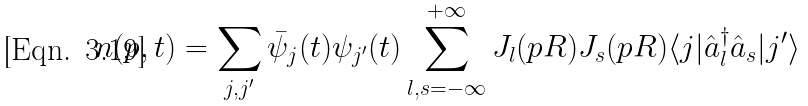Convert formula to latex. <formula><loc_0><loc_0><loc_500><loc_500>n ( p , t ) = \sum _ { j , j ^ { \prime } } \bar { \psi } _ { j } ( t ) \psi _ { j ^ { \prime } } ( t ) \sum _ { l , s = - \infty } ^ { + \infty } J _ { l } ( p R ) J _ { s } ( p R ) \langle j | \hat { a } _ { l } ^ { \dagger } \hat { a } _ { s } | j ^ { \prime } \rangle</formula> 